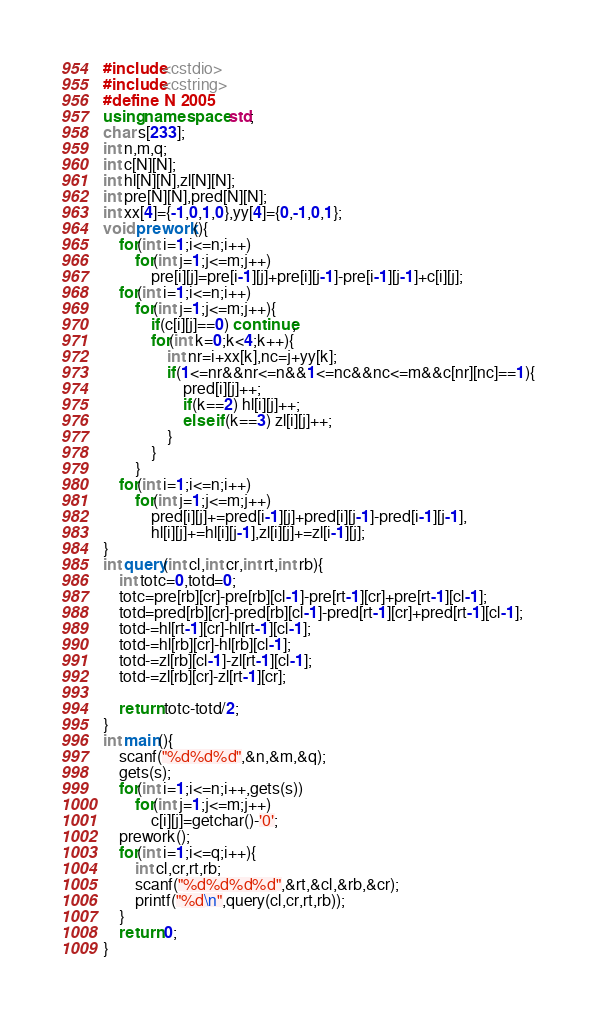Convert code to text. <code><loc_0><loc_0><loc_500><loc_500><_C++_>#include<cstdio>
#include<cstring>
#define N 2005
using namespace std;
char s[233];
int n,m,q;
int c[N][N];
int hl[N][N],zl[N][N];
int pre[N][N],pred[N][N];
int xx[4]={-1,0,1,0},yy[4]={0,-1,0,1};
void prework(){
	for(int i=1;i<=n;i++)
		for(int j=1;j<=m;j++)
			pre[i][j]=pre[i-1][j]+pre[i][j-1]-pre[i-1][j-1]+c[i][j];
	for(int i=1;i<=n;i++)
		for(int j=1;j<=m;j++){
			if(c[i][j]==0) continue;
			for(int k=0;k<4;k++){
				int nr=i+xx[k],nc=j+yy[k];
				if(1<=nr&&nr<=n&&1<=nc&&nc<=m&&c[nr][nc]==1){
					pred[i][j]++;
					if(k==2) hl[i][j]++;
					else if(k==3) zl[i][j]++;
				}
			}
		}
	for(int i=1;i<=n;i++)
		for(int j=1;j<=m;j++)
			pred[i][j]+=pred[i-1][j]+pred[i][j-1]-pred[i-1][j-1],
			hl[i][j]+=hl[i][j-1],zl[i][j]+=zl[i-1][j];
}
int query(int cl,int cr,int rt,int rb){
	int totc=0,totd=0;
	totc=pre[rb][cr]-pre[rb][cl-1]-pre[rt-1][cr]+pre[rt-1][cl-1];
	totd=pred[rb][cr]-pred[rb][cl-1]-pred[rt-1][cr]+pred[rt-1][cl-1];
	totd-=hl[rt-1][cr]-hl[rt-1][cl-1];
	totd-=hl[rb][cr]-hl[rb][cl-1];
	totd-=zl[rb][cl-1]-zl[rt-1][cl-1];
	totd-=zl[rb][cr]-zl[rt-1][cr];
	
	return totc-totd/2;
}
int main(){
	scanf("%d%d%d",&n,&m,&q);
	gets(s);
	for(int i=1;i<=n;i++,gets(s))
		for(int j=1;j<=m;j++)
			c[i][j]=getchar()-'0';
	prework();
	for(int i=1;i<=q;i++){
		int cl,cr,rt,rb;
		scanf("%d%d%d%d",&rt,&cl,&rb,&cr);
		printf("%d\n",query(cl,cr,rt,rb));
	}
	return 0;
}</code> 